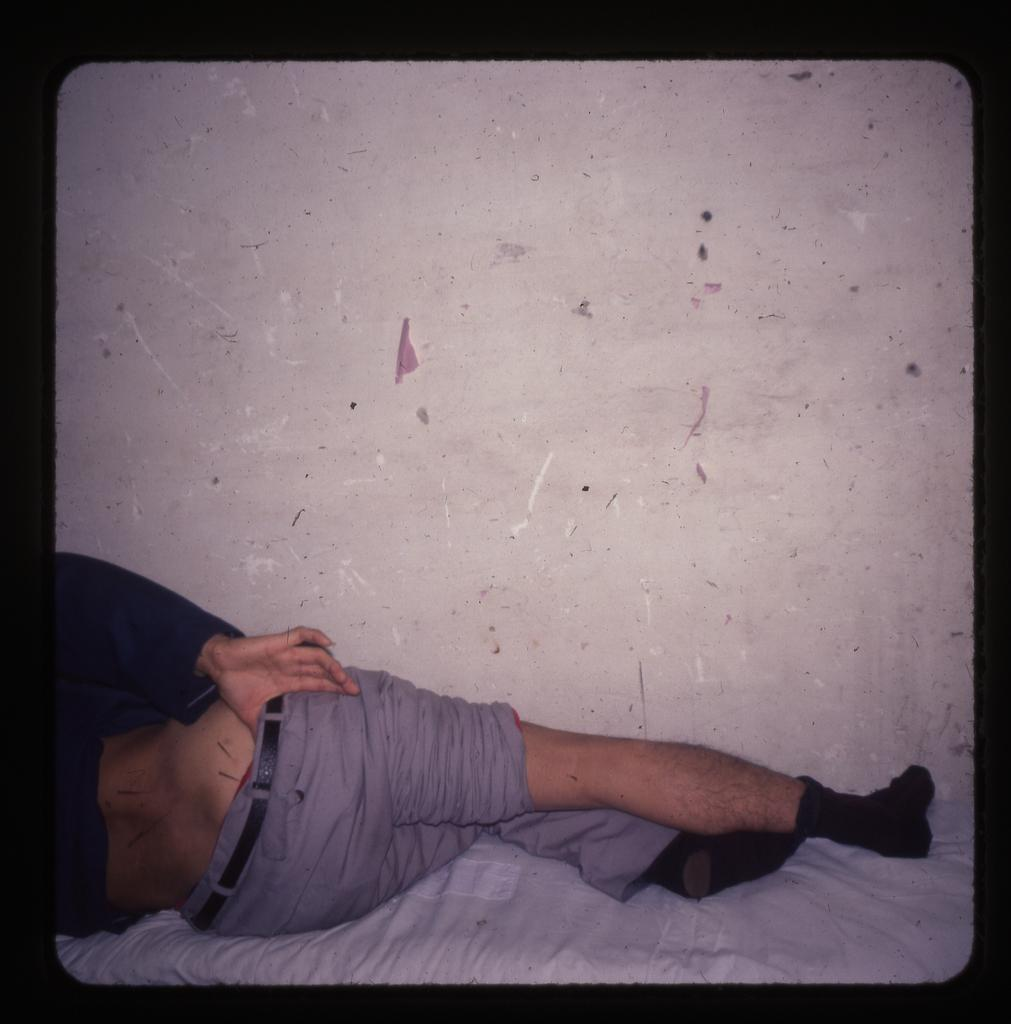What is the main subject of the image? There is a person in the image. What is the person wearing? The person is wearing a black and grey colored dress. What is the person's position in the image? The person is laying on a bed. What is the color of the bed? The bed is white in color. What can be seen in the background of the image? There is a white colored wall in the background of the image. What type of comb can be seen on the marble surface near the harbor in the image? There is no comb, marble surface, or harbor present in the image. 